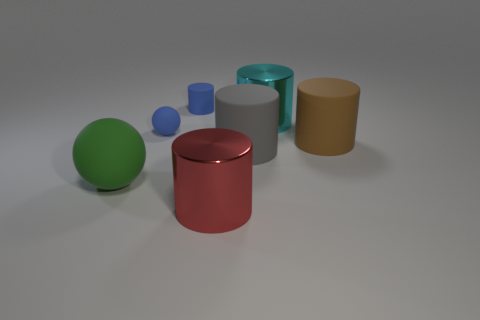Do the small matte sphere and the small rubber cylinder have the same color?
Offer a very short reply. Yes. There is a tiny rubber cylinder; is its color the same as the sphere behind the large green sphere?
Your answer should be very brief. Yes. What material is the cylinder that is both to the left of the big gray object and in front of the blue rubber cylinder?
Make the answer very short. Metal. Is there a blue thing that has the same size as the brown object?
Offer a very short reply. No. What material is the red cylinder that is the same size as the brown rubber cylinder?
Ensure brevity in your answer.  Metal. What number of spheres are in front of the small blue matte sphere?
Offer a very short reply. 1. There is a small rubber object behind the tiny blue matte sphere; does it have the same shape as the large gray object?
Provide a succinct answer. Yes. Is there another thing that has the same shape as the big green thing?
Ensure brevity in your answer.  Yes. There is a blue thing in front of the tiny blue thing that is right of the tiny matte ball; what shape is it?
Make the answer very short. Sphere. How many other large objects have the same material as the big gray thing?
Provide a short and direct response. 2. 